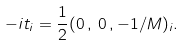<formula> <loc_0><loc_0><loc_500><loc_500>- i t _ { i } = \frac { 1 } { 2 } ( 0 \, , \, 0 \, , - 1 / M ) _ { i } .</formula> 